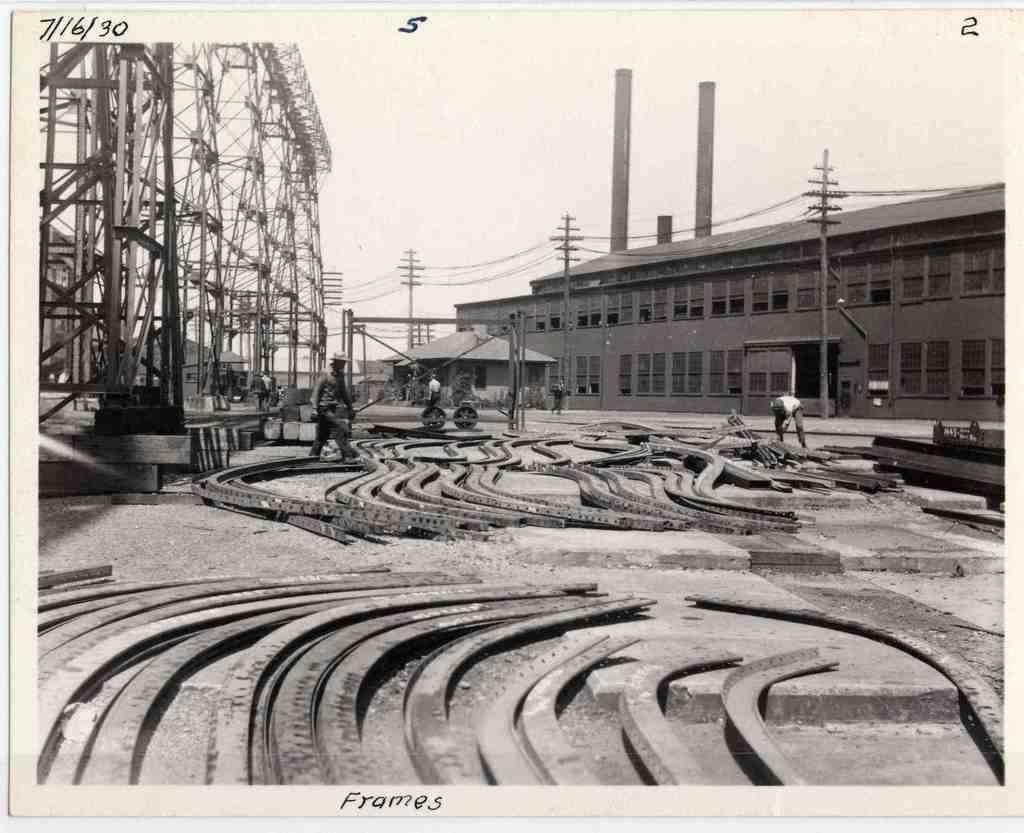What is featured in the image? There is a poster in the image. What types of objects are depicted on the poster? The poster contains metal objects, images of buildings, images of poles, and images of people. What type of paper is used to make the trade in the image? There is no paper or trade present in the image; the poster contains images of metal objects, buildings, poles, and people. 